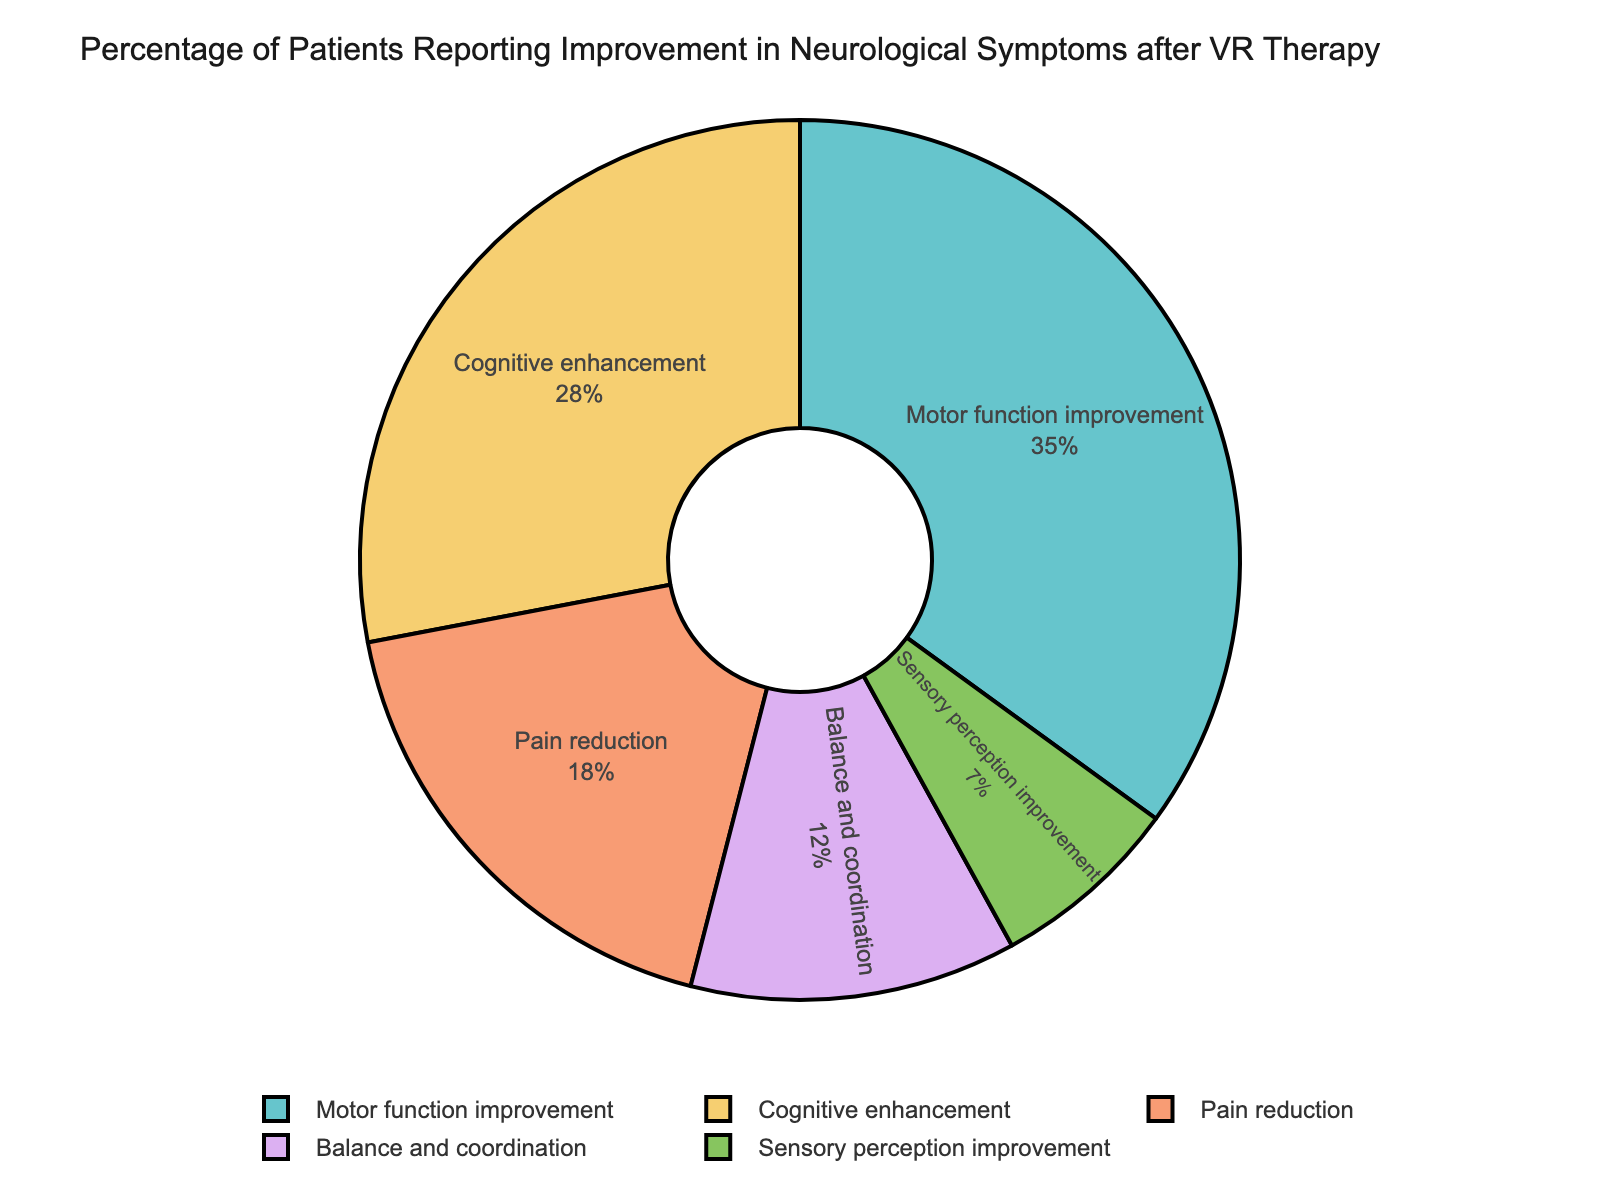What is the most commonly reported improvement? By looking at the figure, the largest segment of the pie chart represents the most commonly reported improvement. This segment is labeled "Motor function improvement" and accounts for 35% of the total.
Answer: Motor function improvement Which symptom has the smallest percentage of reported improvement? The smallest segment of the pie chart is labeled "Sensory perception improvement" and comprises 7% of the total.
Answer: Sensory perception improvement What is the combined percentage of patients who reported improvement in cognitive enhancement and pain reduction? To get the combined percentage, add the percentages of "Cognitive enhancement" (28%) and "Pain reduction" (18%). 28 + 18 = 46%.
Answer: 46% How much more is the percentage of patients reporting motor function improvement compared to those reporting balance and coordination improvement? Subtract the percentage of "Balance and coordination" (12%) from "Motor function improvement" (35%). 35 - 12 = 23%.
Answer: 23% Are there more patients reporting improvements in motor function or cognitive enhancement? By how much? Compare the percentages of "Motor function improvement" (35%) with "Cognitive enhancement" (28%). 35 is greater than 28. The difference is 35 - 28 = 7%.
Answer: Motor function improvement by 7% What percentage of patients reported improvement in functionality that involves physical movement (motor function and balance/coordination)? Add the percentages for "Motor function improvement" (35%) and "Balance and coordination" (12%). 35 + 12 = 47%.
Answer: 47% Which two symptoms combined reported less than 20% of total improvements? The segments for "Balance and coordination" (12%) and "Sensory perception improvement" (7%) together total less than 20%. 12 + 7 = 19%.
Answer: Balance and coordination, Sensory perception improvement Which improvements are reported by fewer than 20% of patients each? The segments for "Balance and coordination" (12%) and "Sensory perception improvement" (7%) each represent less than 20% of the total.
Answer: Balance and coordination, Sensory perception improvement 